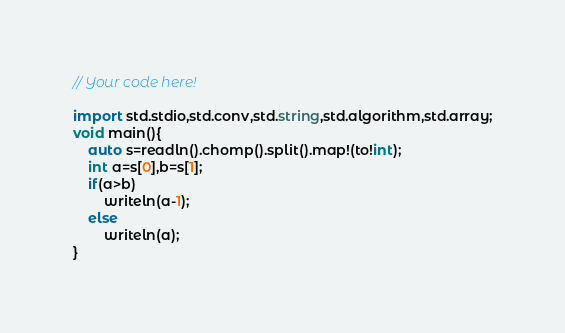Convert code to text. <code><loc_0><loc_0><loc_500><loc_500><_D_>// Your code here!

import std.stdio,std.conv,std.string,std.algorithm,std.array;
void main(){
    auto s=readln().chomp().split().map!(to!int);
    int a=s[0],b=s[1];
    if(a>b)
        writeln(a-1);
    else
        writeln(a);
}</code> 